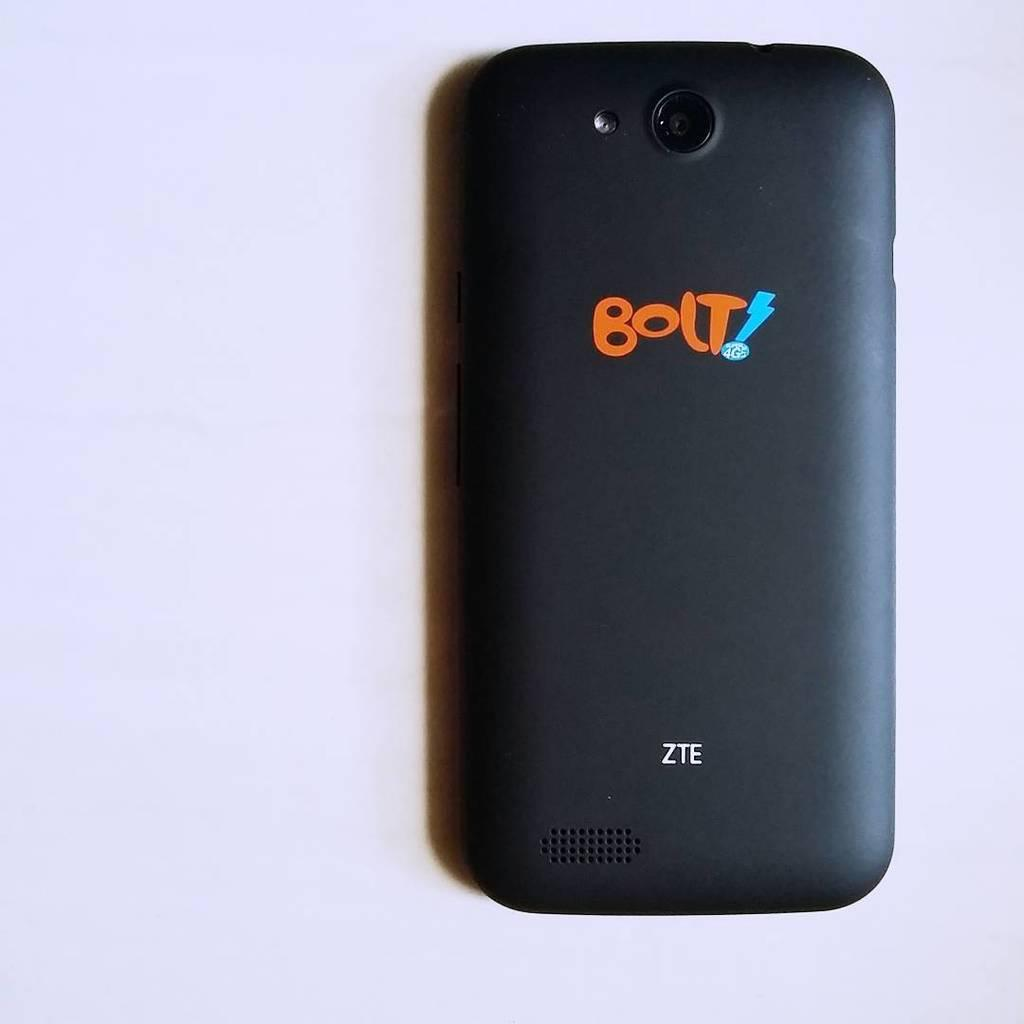Provide a one-sentence caption for the provided image. The black smart phone was emblazoned with BOLT!. 